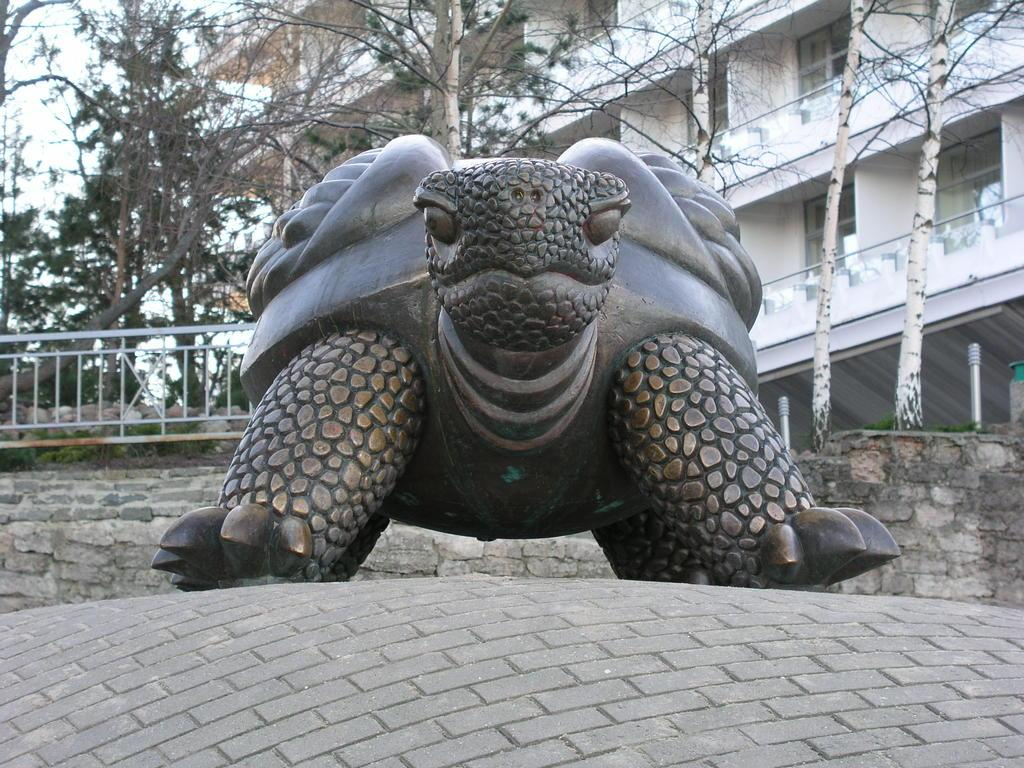What is the main subject of the image? There is a sculpture of a tortoise in the image. Where is the sculpture located? The sculpture is on a platform. What can be seen in the background of the image? There is a building, trees, a fence, poles, and the sky visible in the background of the image. What direction is the donkey facing in the image? There is no donkey present in the image, so it is not possible to determine the direction it might be facing. 